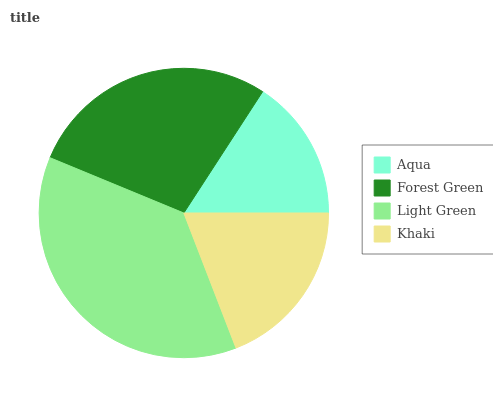Is Aqua the minimum?
Answer yes or no. Yes. Is Light Green the maximum?
Answer yes or no. Yes. Is Forest Green the minimum?
Answer yes or no. No. Is Forest Green the maximum?
Answer yes or no. No. Is Forest Green greater than Aqua?
Answer yes or no. Yes. Is Aqua less than Forest Green?
Answer yes or no. Yes. Is Aqua greater than Forest Green?
Answer yes or no. No. Is Forest Green less than Aqua?
Answer yes or no. No. Is Forest Green the high median?
Answer yes or no. Yes. Is Khaki the low median?
Answer yes or no. Yes. Is Khaki the high median?
Answer yes or no. No. Is Light Green the low median?
Answer yes or no. No. 